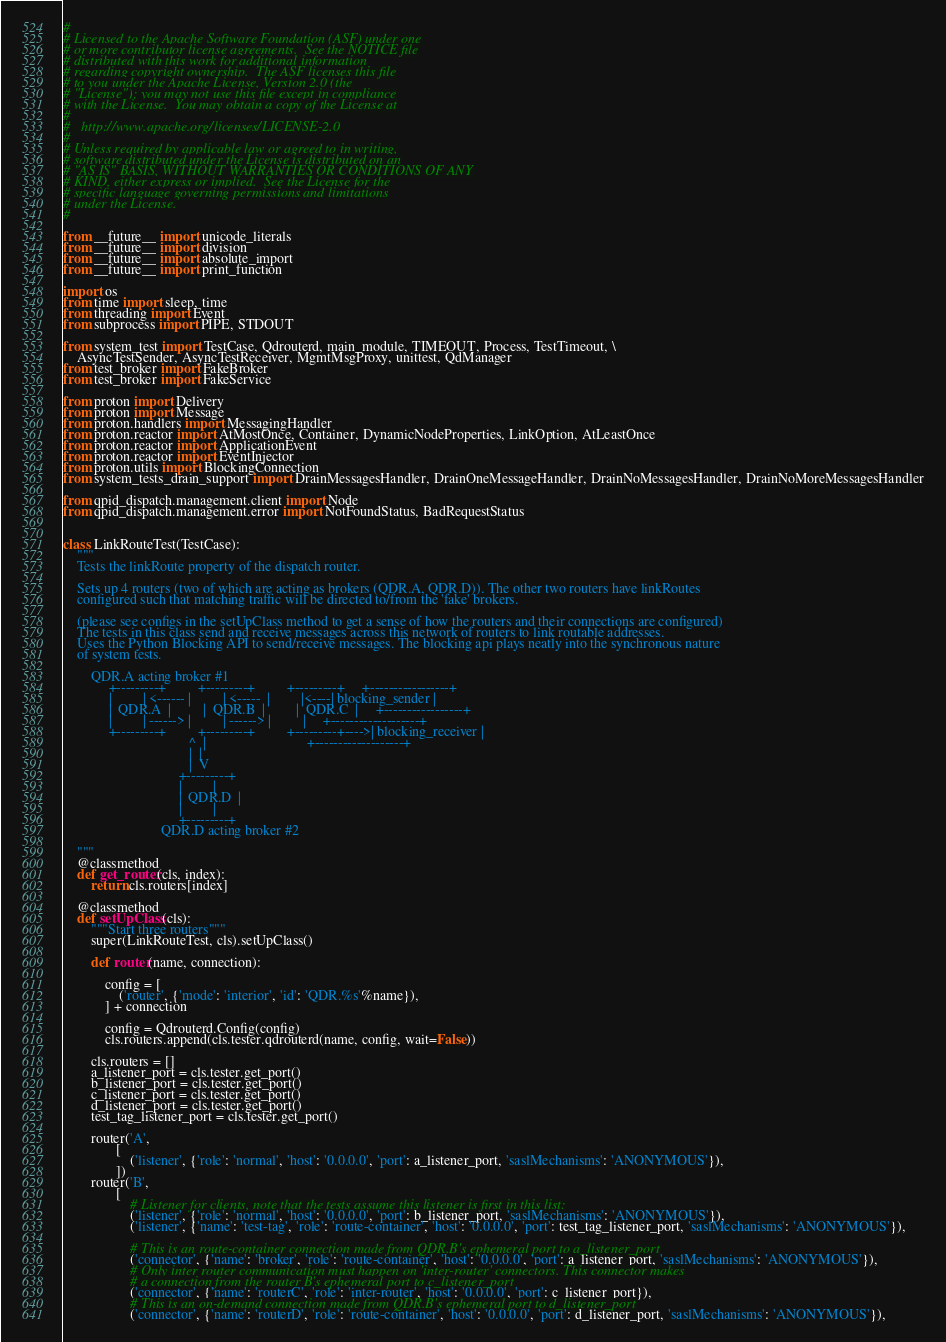Convert code to text. <code><loc_0><loc_0><loc_500><loc_500><_Python_>#
# Licensed to the Apache Software Foundation (ASF) under one
# or more contributor license agreements.  See the NOTICE file
# distributed with this work for additional information
# regarding copyright ownership.  The ASF licenses this file
# to you under the Apache License, Version 2.0 (the
# "License"); you may not use this file except in compliance
# with the License.  You may obtain a copy of the License at
#
#   http://www.apache.org/licenses/LICENSE-2.0
#
# Unless required by applicable law or agreed to in writing,
# software distributed under the License is distributed on an
# "AS IS" BASIS, WITHOUT WARRANTIES OR CONDITIONS OF ANY
# KIND, either express or implied.  See the License for the
# specific language governing permissions and limitations
# under the License.
#

from __future__ import unicode_literals
from __future__ import division
from __future__ import absolute_import
from __future__ import print_function

import os
from time import sleep, time
from threading import Event
from subprocess import PIPE, STDOUT

from system_test import TestCase, Qdrouterd, main_module, TIMEOUT, Process, TestTimeout, \
    AsyncTestSender, AsyncTestReceiver, MgmtMsgProxy, unittest, QdManager
from test_broker import FakeBroker
from test_broker import FakeService

from proton import Delivery
from proton import Message
from proton.handlers import MessagingHandler
from proton.reactor import AtMostOnce, Container, DynamicNodeProperties, LinkOption, AtLeastOnce
from proton.reactor import ApplicationEvent
from proton.reactor import EventInjector
from proton.utils import BlockingConnection
from system_tests_drain_support import DrainMessagesHandler, DrainOneMessageHandler, DrainNoMessagesHandler, DrainNoMoreMessagesHandler

from qpid_dispatch.management.client import Node
from qpid_dispatch.management.error import NotFoundStatus, BadRequestStatus


class LinkRouteTest(TestCase):
    """
    Tests the linkRoute property of the dispatch router.

    Sets up 4 routers (two of which are acting as brokers (QDR.A, QDR.D)). The other two routers have linkRoutes
    configured such that matching traffic will be directed to/from the 'fake' brokers.

    (please see configs in the setUpClass method to get a sense of how the routers and their connections are configured)
    The tests in this class send and receive messages across this network of routers to link routable addresses.
    Uses the Python Blocking API to send/receive messages. The blocking api plays neatly into the synchronous nature
    of system tests.

        QDR.A acting broker #1
             +---------+         +---------+         +---------+     +-----------------+
             |         | <------ |         | <-----  |         |<----| blocking_sender |
             |  QDR.A  |         |  QDR.B  |         |  QDR.C  |     +-----------------+
             |         | ------> |         | ------> |         |     +-------------------+
             +---------+         +---------+         +---------+---->| blocking_receiver |
                                    ^  |                             +-------------------+
                                    |  |
                                    |  V
                                 +---------+
                                 |         |
                                 |  QDR.D  |
                                 |         |
                                 +---------+
                            QDR.D acting broker #2

    """
    @classmethod
    def get_router(cls, index):
        return cls.routers[index]

    @classmethod
    def setUpClass(cls):
        """Start three routers"""
        super(LinkRouteTest, cls).setUpClass()

        def router(name, connection):

            config = [
                ('router', {'mode': 'interior', 'id': 'QDR.%s'%name}),
            ] + connection

            config = Qdrouterd.Config(config)
            cls.routers.append(cls.tester.qdrouterd(name, config, wait=False))

        cls.routers = []
        a_listener_port = cls.tester.get_port()
        b_listener_port = cls.tester.get_port()
        c_listener_port = cls.tester.get_port()
        d_listener_port = cls.tester.get_port()
        test_tag_listener_port = cls.tester.get_port()

        router('A',
               [
                   ('listener', {'role': 'normal', 'host': '0.0.0.0', 'port': a_listener_port, 'saslMechanisms': 'ANONYMOUS'}),
               ])
        router('B',
               [
                   # Listener for clients, note that the tests assume this listener is first in this list:
                   ('listener', {'role': 'normal', 'host': '0.0.0.0', 'port': b_listener_port, 'saslMechanisms': 'ANONYMOUS'}),
                   ('listener', {'name': 'test-tag', 'role': 'route-container', 'host': '0.0.0.0', 'port': test_tag_listener_port, 'saslMechanisms': 'ANONYMOUS'}),

                   # This is an route-container connection made from QDR.B's ephemeral port to a_listener_port
                   ('connector', {'name': 'broker', 'role': 'route-container', 'host': '0.0.0.0', 'port': a_listener_port, 'saslMechanisms': 'ANONYMOUS'}),
                   # Only inter router communication must happen on 'inter-router' connectors. This connector makes
                   # a connection from the router B's ephemeral port to c_listener_port
                   ('connector', {'name': 'routerC', 'role': 'inter-router', 'host': '0.0.0.0', 'port': c_listener_port}),
                   # This is an on-demand connection made from QDR.B's ephemeral port to d_listener_port
                   ('connector', {'name': 'routerD', 'role': 'route-container', 'host': '0.0.0.0', 'port': d_listener_port, 'saslMechanisms': 'ANONYMOUS'}),
</code> 